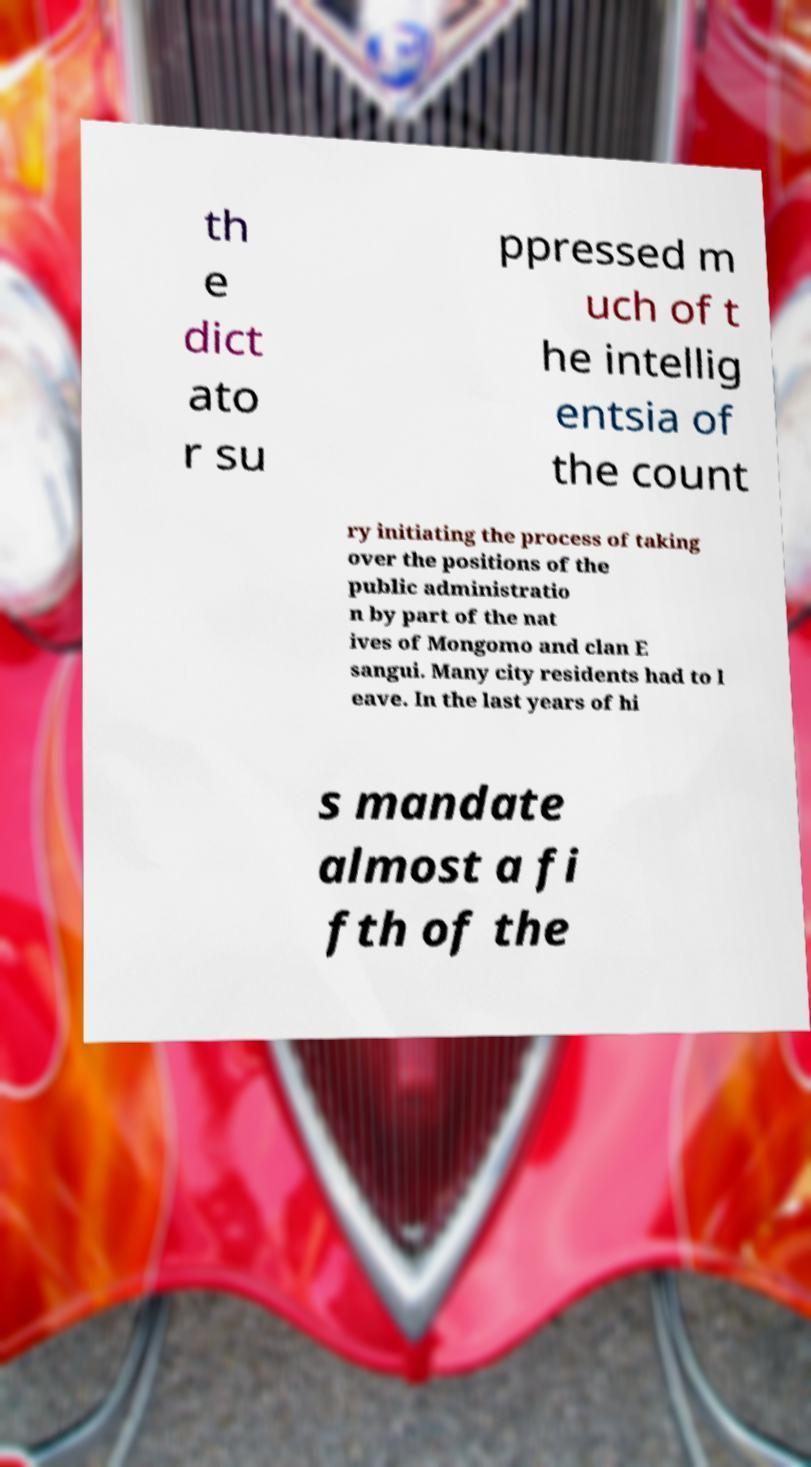Can you accurately transcribe the text from the provided image for me? th e dict ato r su ppressed m uch of t he intellig entsia of the count ry initiating the process of taking over the positions of the public administratio n by part of the nat ives of Mongomo and clan E sangui. Many city residents had to l eave. In the last years of hi s mandate almost a fi fth of the 